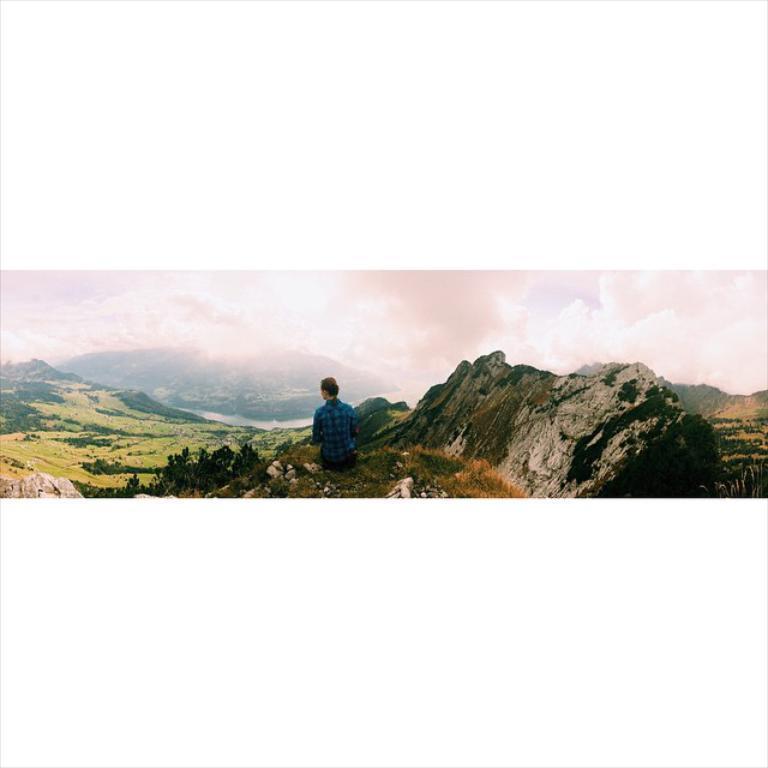Describe this image in one or two sentences. This picture might be taken from outside of the city. In this image, in the middle, we can see a person sitting on the rock. On the right side, we can see some rocks and trees. On the left side, we can also see some rocks and trees. In the background, we can see some mountains. On the top, we can see a sky which is cloudy, at the bottom there are some trees, plants and stones. 